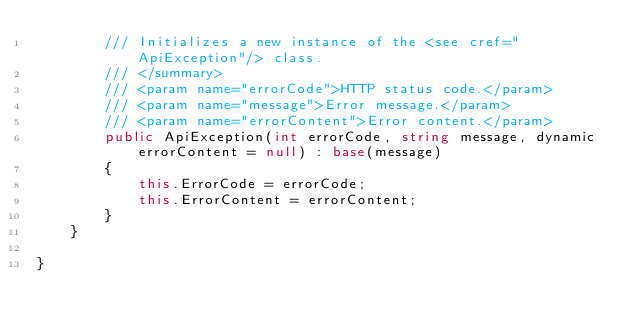<code> <loc_0><loc_0><loc_500><loc_500><_C#_>        /// Initializes a new instance of the <see cref="ApiException"/> class.
        /// </summary>
        /// <param name="errorCode">HTTP status code.</param>
        /// <param name="message">Error message.</param>
        /// <param name="errorContent">Error content.</param>
        public ApiException(int errorCode, string message, dynamic errorContent = null) : base(message)
        {
            this.ErrorCode = errorCode;
            this.ErrorContent = errorContent;
        }
    }

}
</code> 